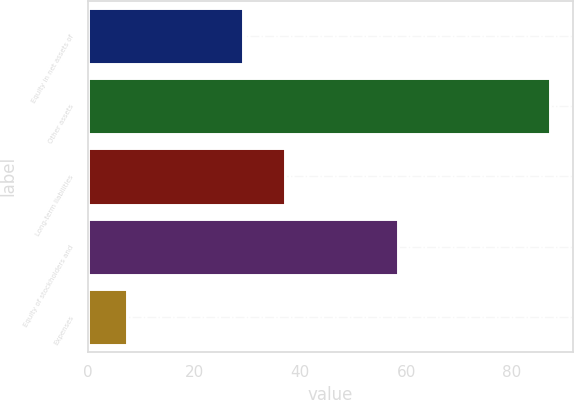Convert chart. <chart><loc_0><loc_0><loc_500><loc_500><bar_chart><fcel>Equity in net assets of<fcel>Other assets<fcel>Long-term liabilities<fcel>Equity of stockholders and<fcel>Expenses<nl><fcel>29.2<fcel>87.1<fcel>37.17<fcel>58.4<fcel>7.4<nl></chart> 